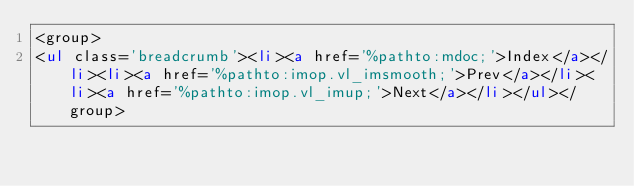Convert code to text. <code><loc_0><loc_0><loc_500><loc_500><_HTML_><group>
<ul class='breadcrumb'><li><a href='%pathto:mdoc;'>Index</a></li><li><a href='%pathto:imop.vl_imsmooth;'>Prev</a></li><li><a href='%pathto:imop.vl_imup;'>Next</a></li></ul></group>
</code> 